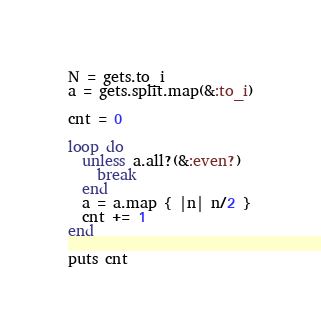Convert code to text. <code><loc_0><loc_0><loc_500><loc_500><_Ruby_>N = gets.to_i
a = gets.split.map(&:to_i)

cnt = 0

loop do
  unless a.all?(&:even?)
    break
  end
  a = a.map { |n| n/2 }
  cnt += 1
end

puts cnt</code> 